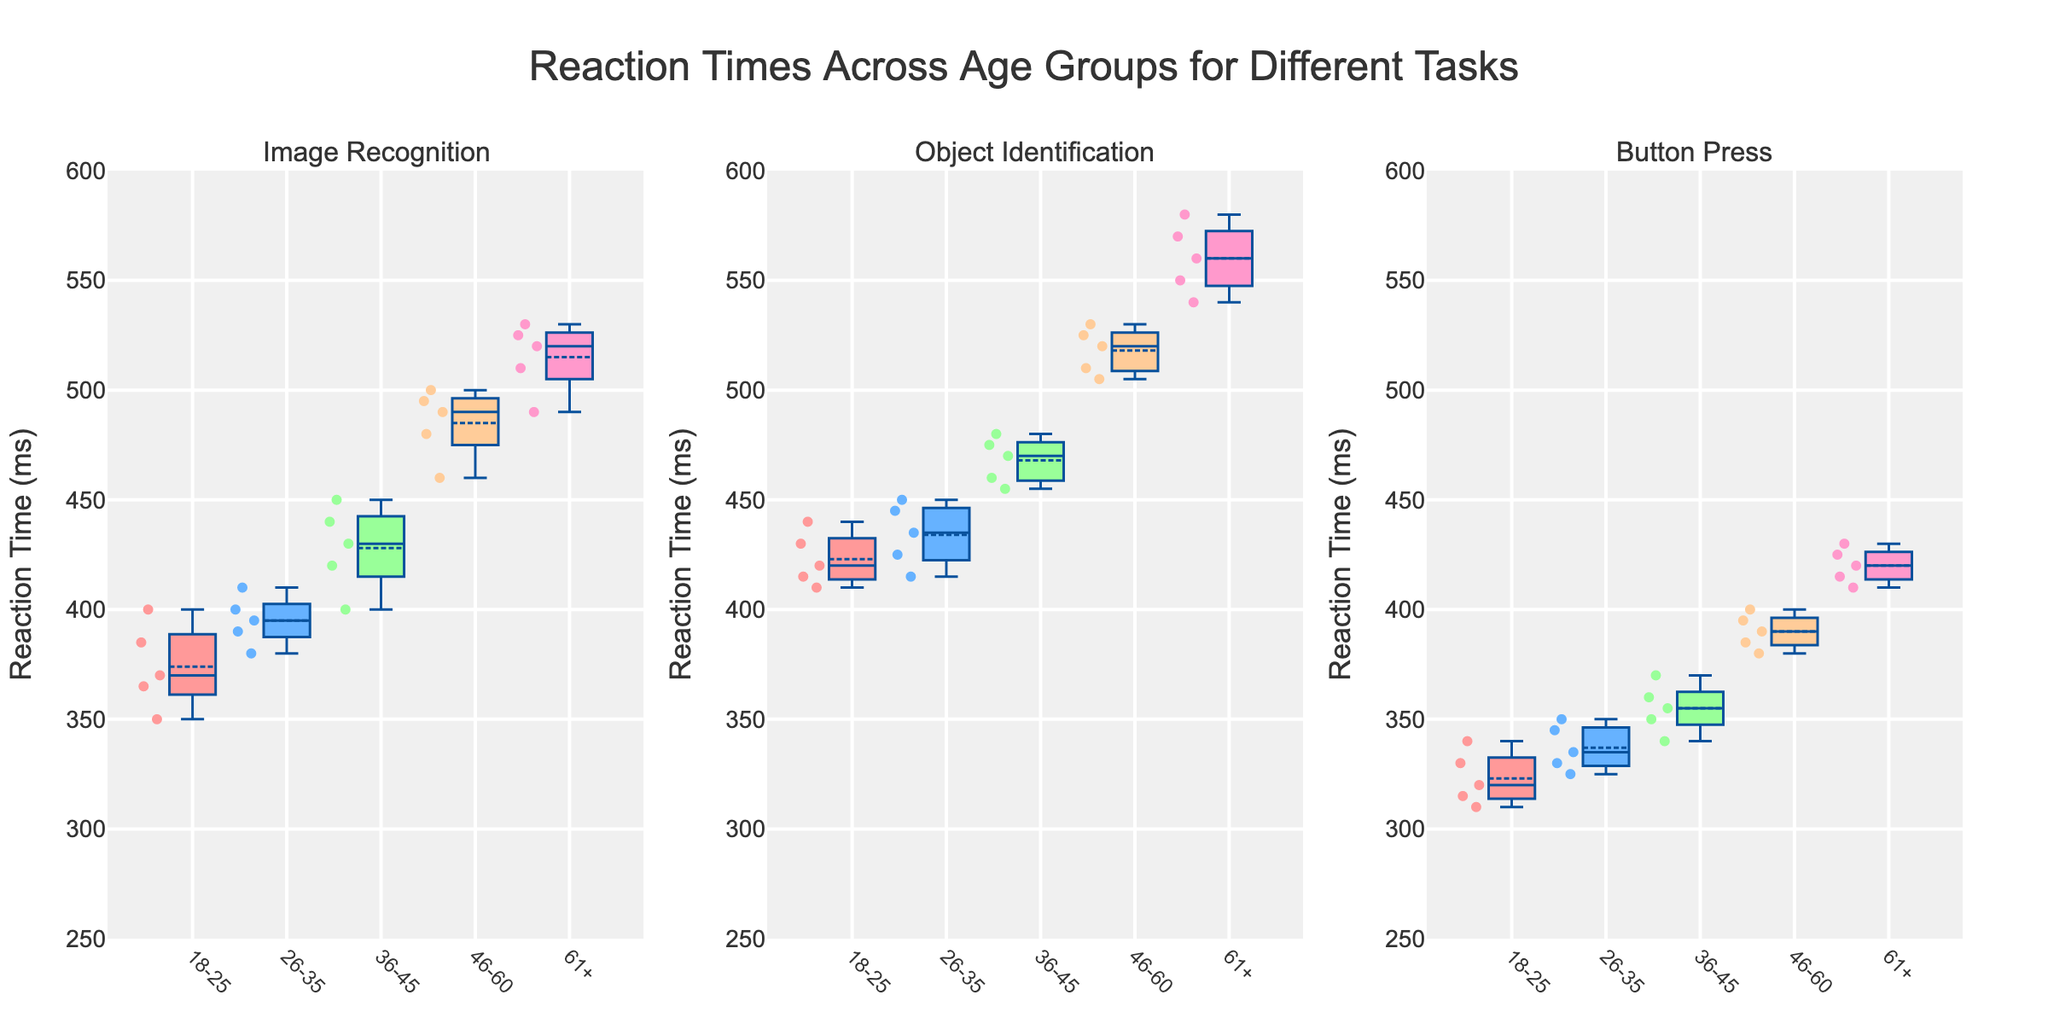What are the tasks shown in the figure? The figure shows subplots for multiple tasks, which can be identified by the subplot titles. The titles are "Image Recognition," "Object Identification," and "Button Press."
Answer: Image Recognition, Object Identification, Button Press What does the y-axis represent in all the subplots? The y-axis label across all the subplots is "Reaction Time (ms)," indicating that it represents the reaction times measured in milliseconds.
Answer: Reaction Time (ms) Which age group has the highest median reaction time for the task "Image Recognition"? To find the median reaction time, look for the center line inside each box plot under the "Image Recognition" subplot. The age group "61+" has the highest median reaction time.
Answer: 61+ How do the reaction times for "Button Press" among age groups 18-25 and 46-60 compare? Compare the medians of the box plots for the "Button Press" subplot. The median reaction time for age group 18-25 is lower than for 46-60.
Answer: 18-25 is faster What is the mean reaction time for the 26-35 age group in the "Object Identification" task? The mean is represented by the small box inside each box plot. Locate this for the 26-35 age group under the "Object Identification" subplot.
Answer: Around 432 ms Is there an age group that consistently performs better across all tasks? To determine this, compare the medians of each age group's box plots across all three subplots. The age group 18-25 consistently has lower median reaction times across all tasks.
Answer: 18-25 What is the interquartile range (IQR) for the 36-45 age group in the "Button Press" task? The IQR is the range between the 25th and 75th percentiles (the bottom and top of the box). For age group 36-45 in the "Button Press" subplot, measure this range visually.
Answer: 10 ms (approx 340 ms to 350 ms) Which task shows the greatest variability in reaction times for the age group 46-60? Variability can be assessed by the spread of the data points and the range of the box plots and whiskers. The "Object Identification" task for 46-60 shows the greatest variability with longer whiskers and a wider box.
Answer: Object Identification Are there any outliers in the "Button Press" task for the age group 18-25? Outliers in box plots are typically represented by individual points outside the whiskers. For age group 18-25 in the "Button Press" subplot, there do not appear to be any outliers.
Answer: No 